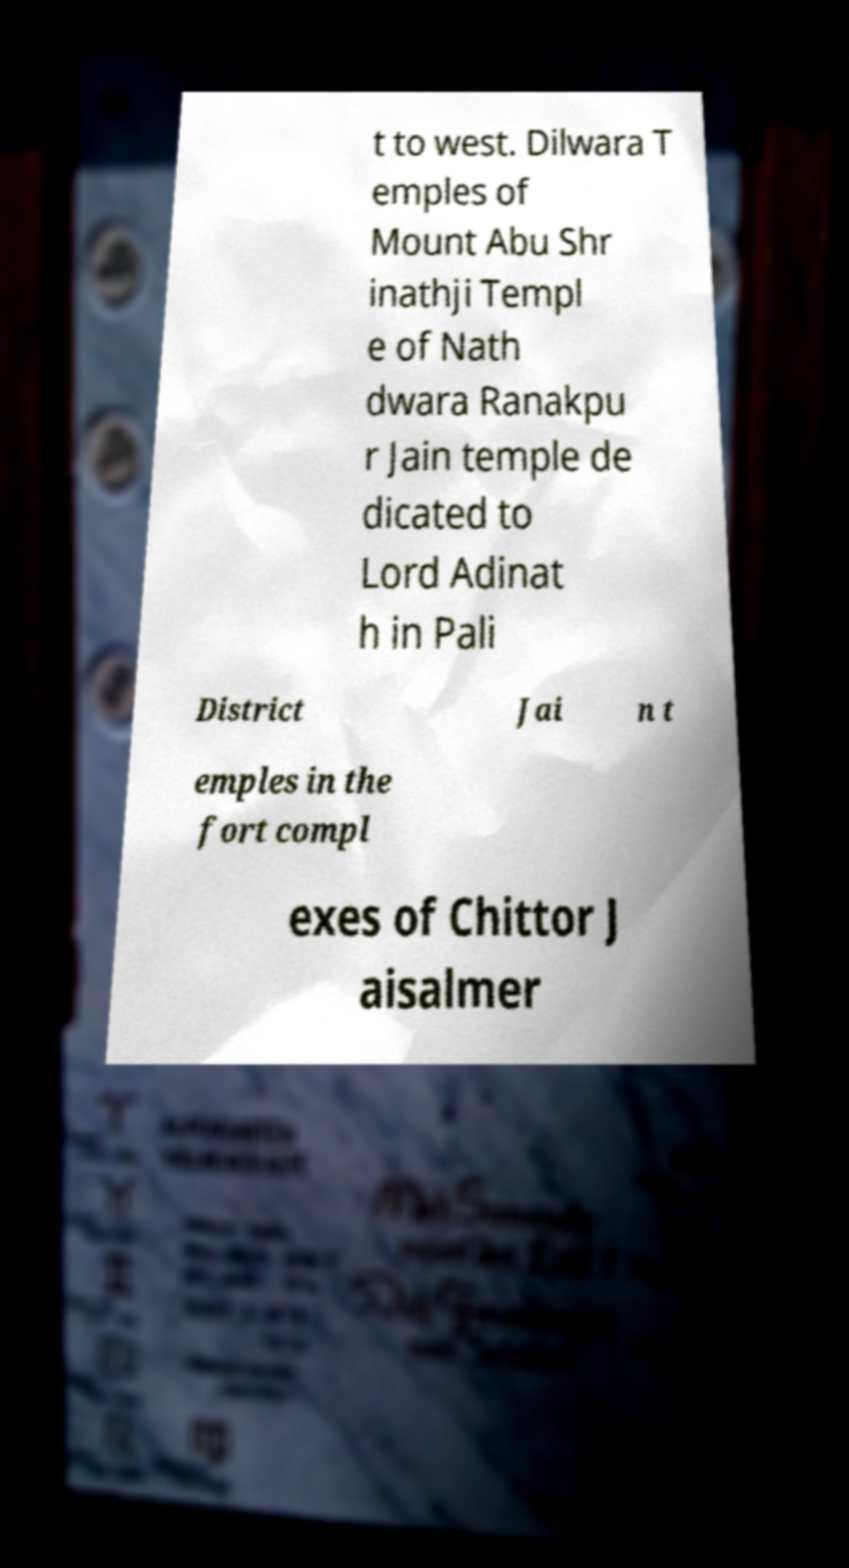Can you read and provide the text displayed in the image?This photo seems to have some interesting text. Can you extract and type it out for me? t to west. Dilwara T emples of Mount Abu Shr inathji Templ e of Nath dwara Ranakpu r Jain temple de dicated to Lord Adinat h in Pali District Jai n t emples in the fort compl exes of Chittor J aisalmer 